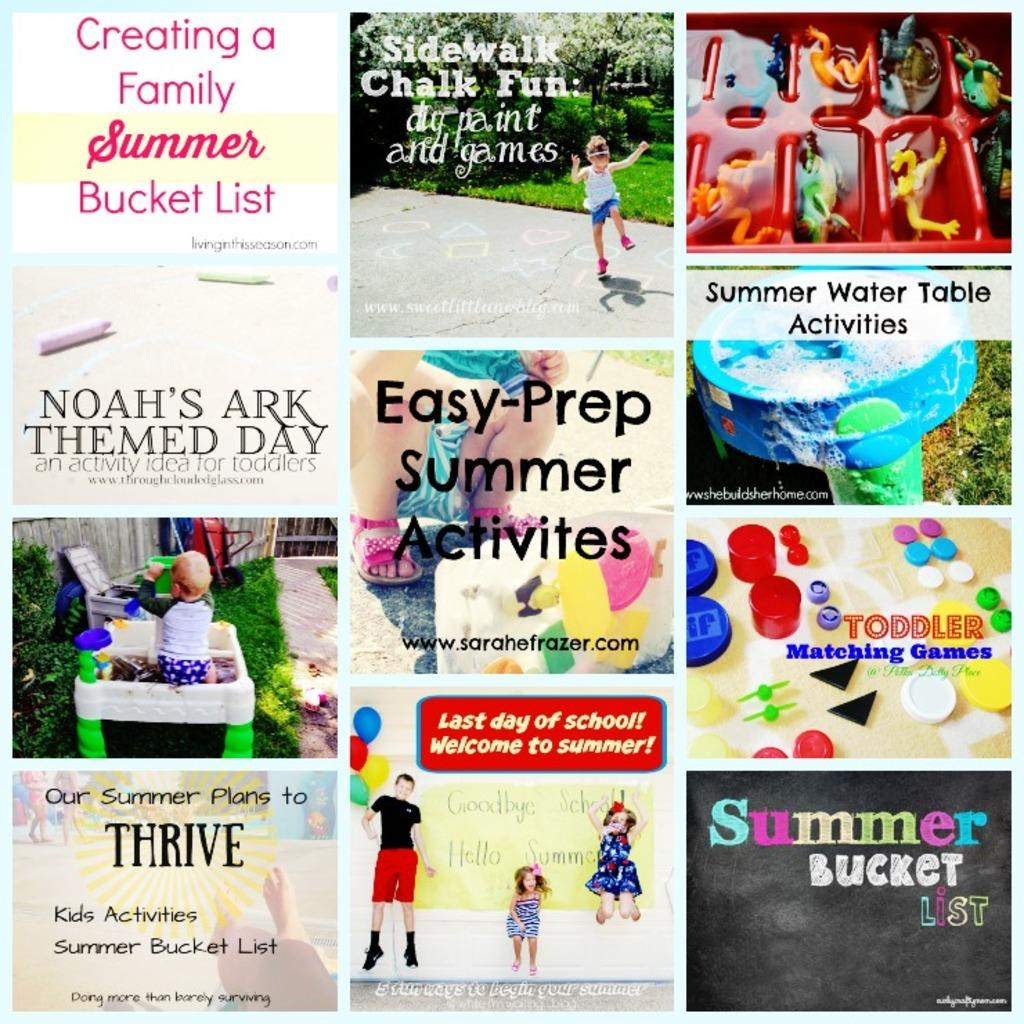What type of images are included in the collage? There are images of children in the collage. Are there any words or phrases written on the images? Yes, there are texts written on some of the images. What other items can be seen in the collage besides the images of children? There are toys visible in the collage. Can you describe the variety of objects present in the collage? There are various objects present in the collage, including toys and images with text. What color is the brain in the collage? There is no brain present in the collage; it consists of images of children, texts, toys, and various objects. 